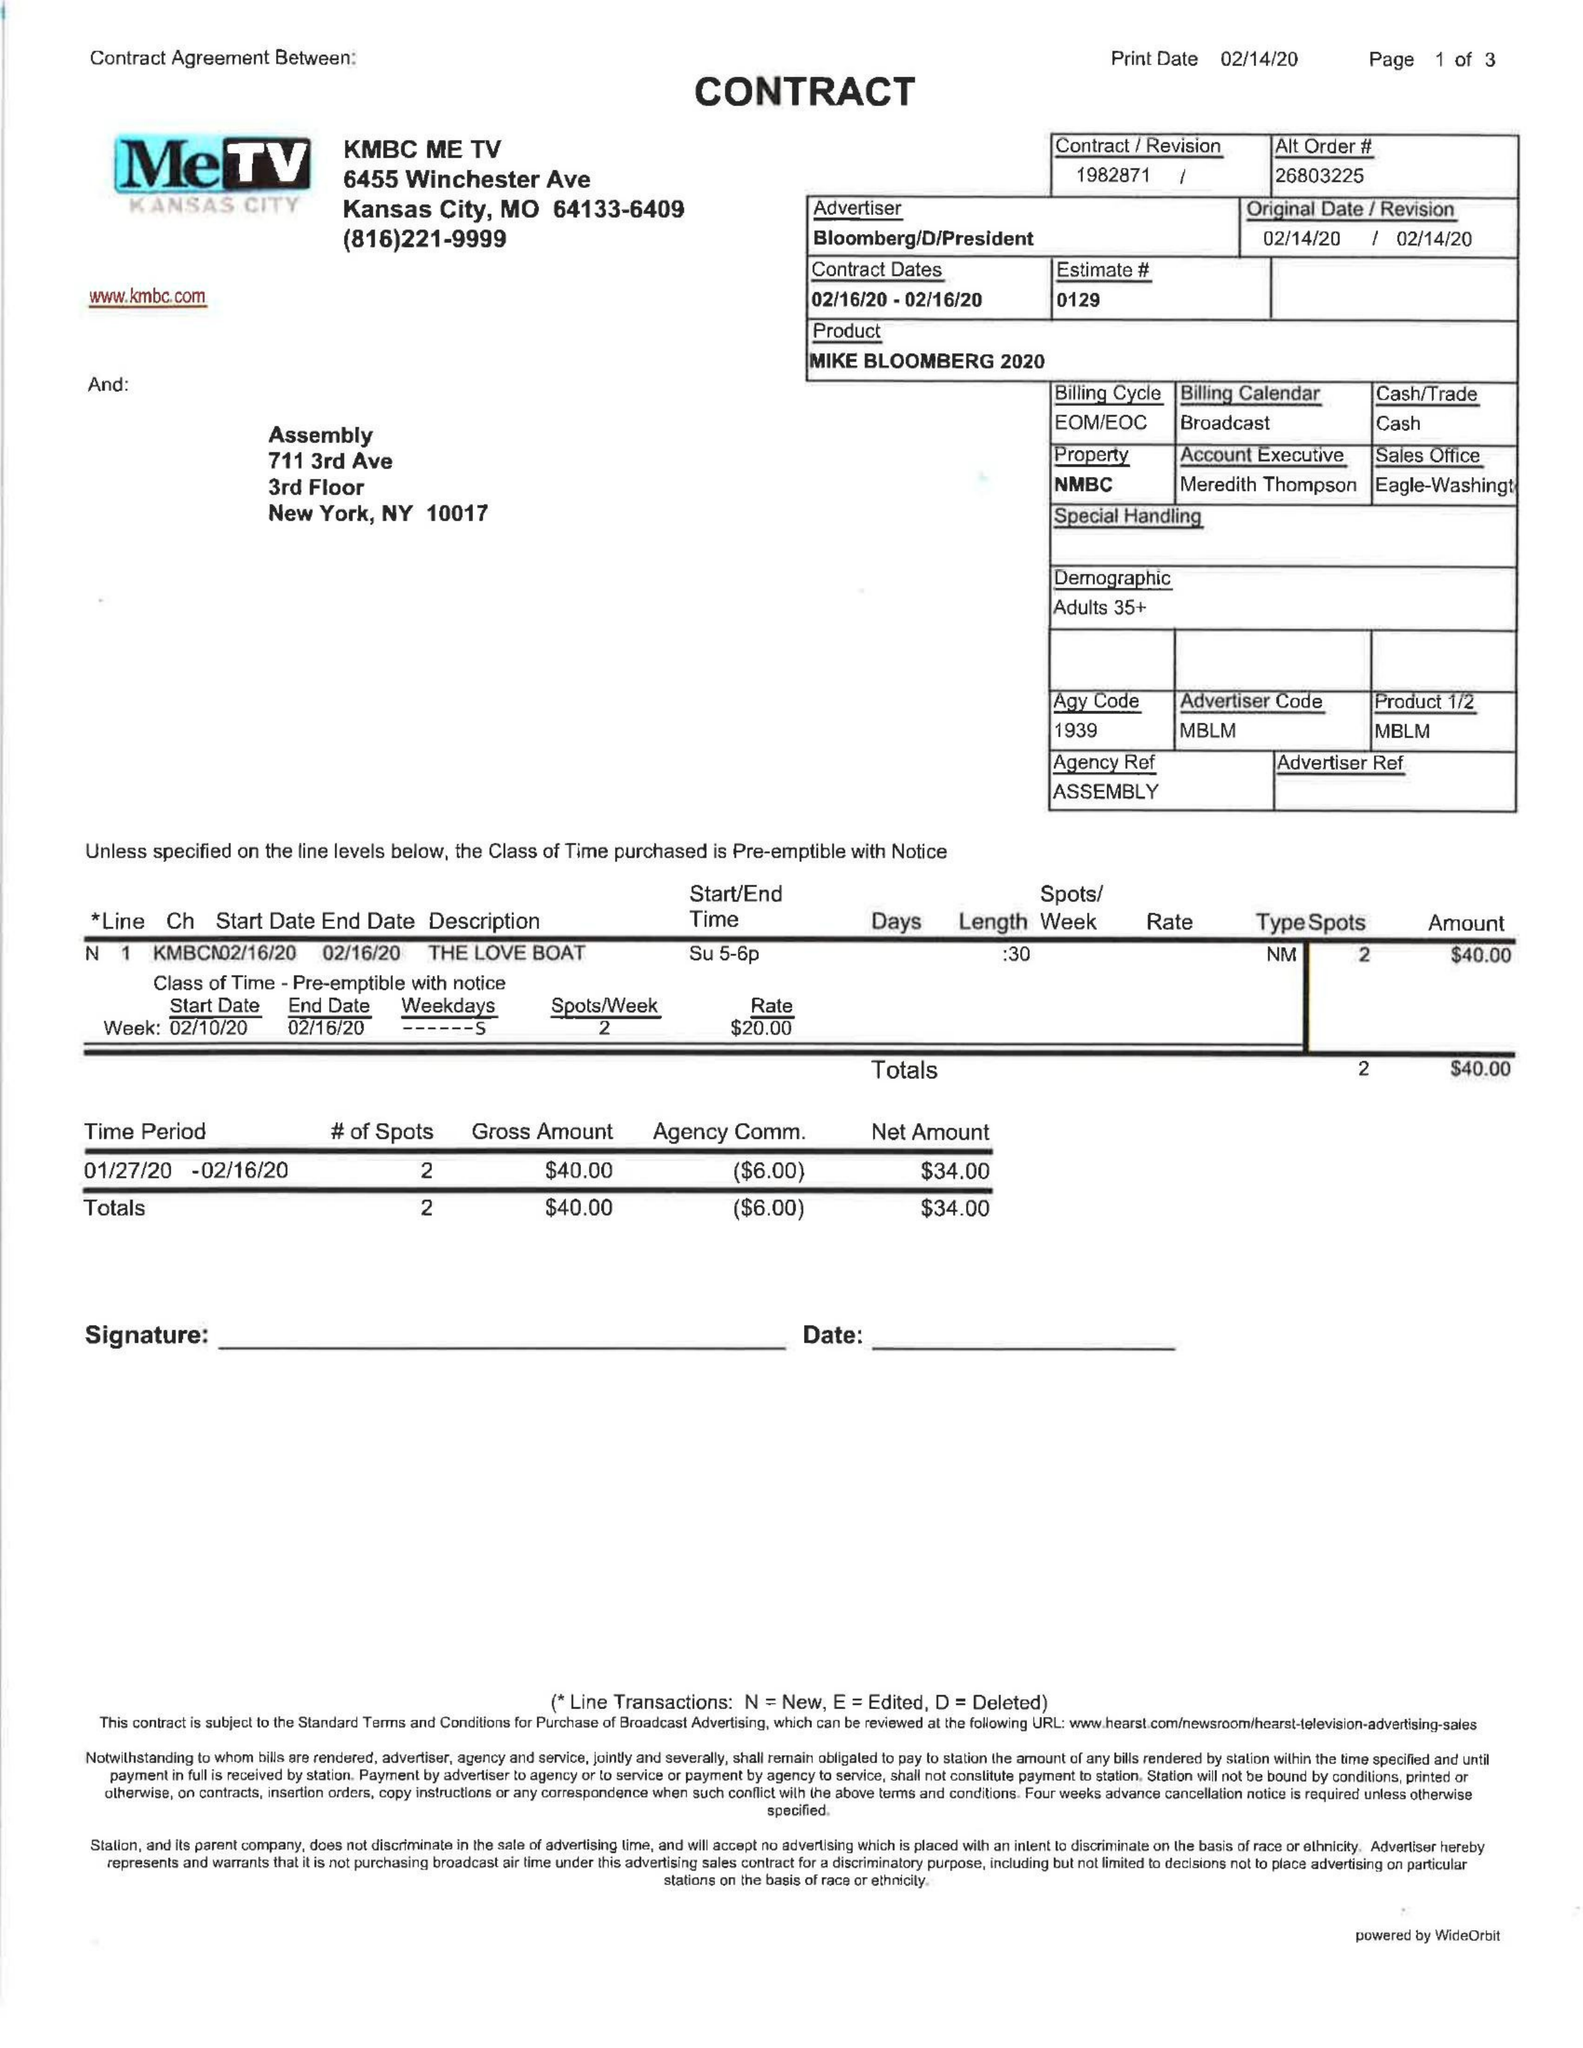What is the value for the flight_from?
Answer the question using a single word or phrase. 02/16/20 